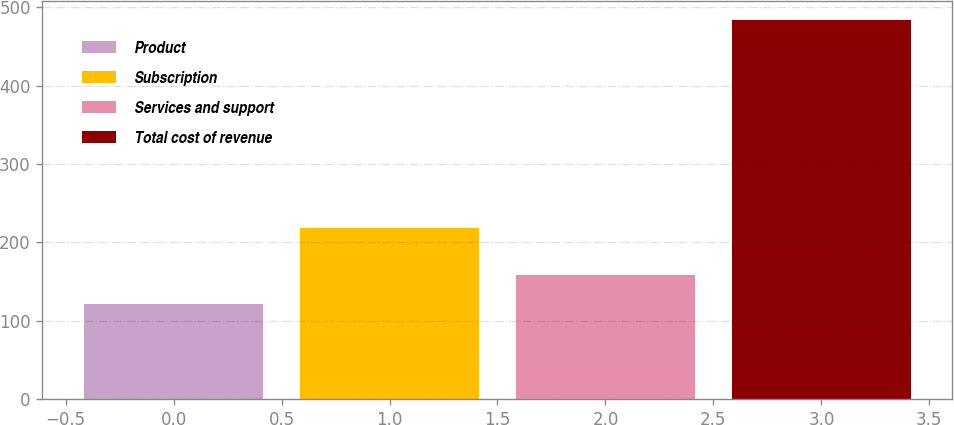<chart> <loc_0><loc_0><loc_500><loc_500><bar_chart><fcel>Product<fcel>Subscription<fcel>Services and support<fcel>Total cost of revenue<nl><fcel>121.7<fcel>219.1<fcel>157.91<fcel>483.8<nl></chart> 